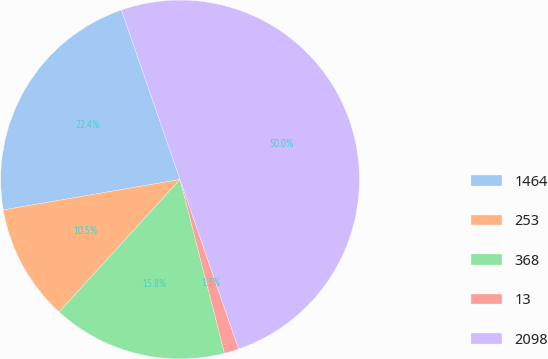<chart> <loc_0><loc_0><loc_500><loc_500><pie_chart><fcel>1464<fcel>253<fcel>368<fcel>13<fcel>2098<nl><fcel>22.42%<fcel>10.51%<fcel>15.76%<fcel>1.31%<fcel>50.0%<nl></chart> 